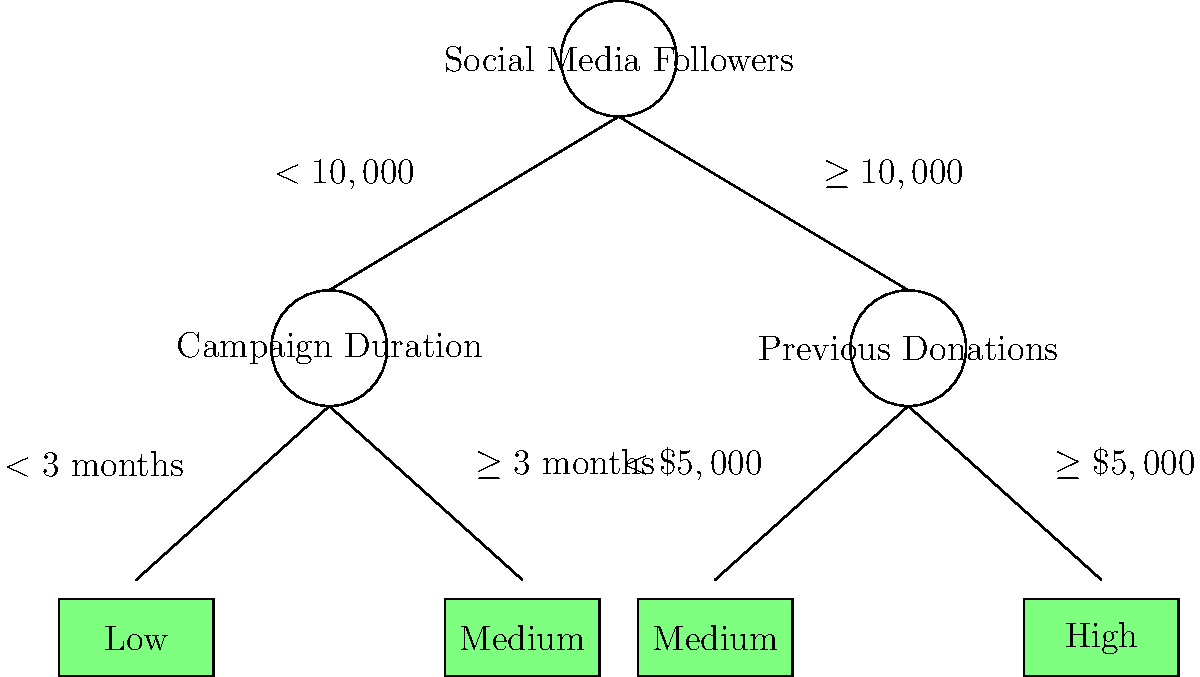Based on the decision tree shown, which combination of factors would most likely result in a "High" prediction for fundraising success? To determine the combination of factors that would lead to a "High" prediction for fundraising success, we need to follow the path in the decision tree that leads to the "High" leaf. Let's break it down step by step:

1. The root node is "Social Media Followers":
   - We need to follow the path where the number of followers is $\geq 10,000$.

2. The next node is "Previous Donations":
   - To reach the "High" leaf, we need to follow the path where previous donations are $\geq \$5,000$.

3. Following this path leads directly to the "High" leaf.

Therefore, the combination of factors that would most likely result in a "High" prediction for fundraising success is:
- Social Media Followers: $\geq 10,000$
- Previous Donations: $\geq \$5,000$

It's worth noting that the "Campaign Duration" factor doesn't come into play for the "High" prediction, as it's only considered when the number of social media followers is less than 10,000.
Answer: $\geq 10,000$ social media followers and $\geq \$5,000$ in previous donations 